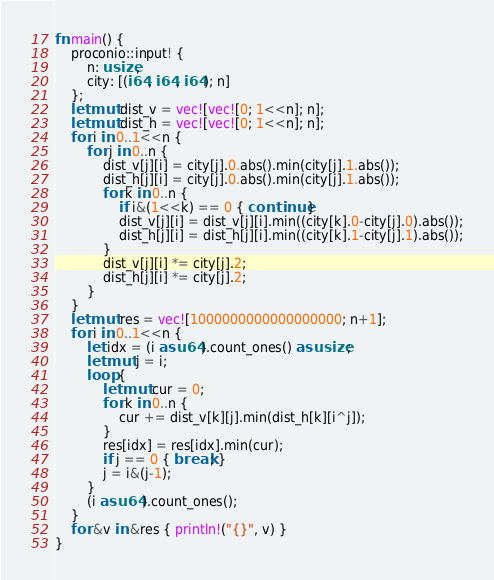Convert code to text. <code><loc_0><loc_0><loc_500><loc_500><_Rust_>fn main() {
    proconio::input! {
        n: usize,
        city: [(i64, i64, i64); n]
    };
    let mut dist_v = vec![vec![0; 1<<n]; n];
    let mut dist_h = vec![vec![0; 1<<n]; n];
    for i in 0..1<<n {
        for j in 0..n {
            dist_v[j][i] = city[j].0.abs().min(city[j].1.abs());
            dist_h[j][i] = city[j].0.abs().min(city[j].1.abs());
            for k in 0..n {
                if i&(1<<k) == 0 { continue }
                dist_v[j][i] = dist_v[j][i].min((city[k].0-city[j].0).abs());
                dist_h[j][i] = dist_h[j][i].min((city[k].1-city[j].1).abs());
            }
            dist_v[j][i] *= city[j].2;
            dist_h[j][i] *= city[j].2;
        }
    }
    let mut res = vec![1000000000000000000; n+1];
    for i in 0..1<<n {
        let idx = (i as u64).count_ones() as usize;
        let mut j = i;
        loop {
            let mut cur = 0;
            for k in 0..n {
                cur += dist_v[k][j].min(dist_h[k][i^j]);
            }
            res[idx] = res[idx].min(cur);
            if j == 0 { break; }
            j = i&(j-1);
        }
        (i as u64).count_ones();
    }
    for &v in &res { println!("{}", v) }
}
</code> 